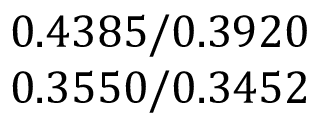Convert formula to latex. <formula><loc_0><loc_0><loc_500><loc_500>\begin{array} { c } { 0 . 4 3 8 5 / 0 . 3 9 2 0 } \\ { 0 . 3 5 5 0 / 0 . 3 4 5 2 } \end{array}</formula> 